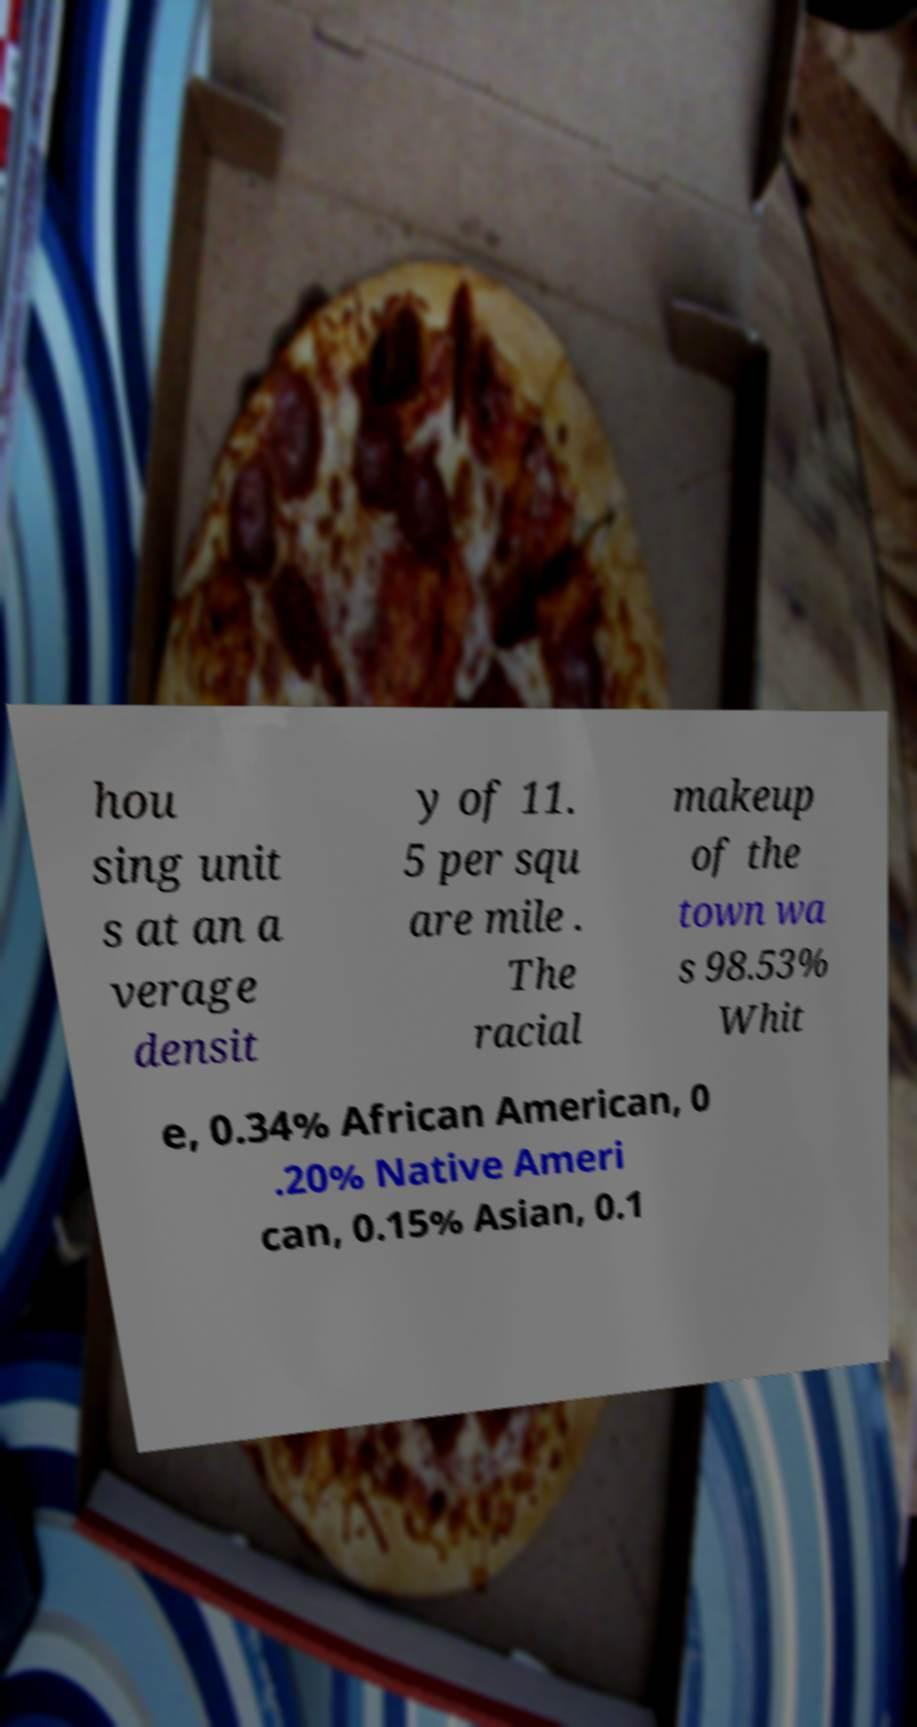I need the written content from this picture converted into text. Can you do that? hou sing unit s at an a verage densit y of 11. 5 per squ are mile . The racial makeup of the town wa s 98.53% Whit e, 0.34% African American, 0 .20% Native Ameri can, 0.15% Asian, 0.1 